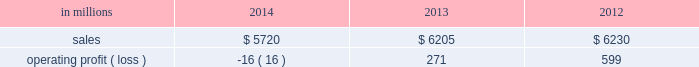Regions .
Principal cost drivers include manufacturing efficiency , raw material and energy costs and freight costs .
Printing papers net sales for 2014 decreased 8% ( 8 % ) to $ 5.7 billion compared with $ 6.2 billion in 2013 and 8% ( 8 % ) compared with $ 6.2 billion in 2012 .
Operating profits in 2014 were 106% ( 106 % ) lower than in 2013 and 103% ( 103 % ) lower than in 2012 .
Excluding facility closure costs , impairment costs and other special items , operating profits in 2014 were 7% ( 7 % ) higher than in 2013 and 8% ( 8 % ) lower than in 2012 .
Benefits from higher average sales price realizations and a favorable mix ( $ 178 million ) , lower planned maintenance downtime costs ( $ 26 million ) , the absence of a provision for bad debt related to a large envelope customer that was booked in 2013 ( $ 28 million ) , and lower foreign exchange and other costs ( $ 25 million ) were offset by lower sales volumes ( $ 82 million ) , higher operating costs ( $ 49 million ) , higher input costs ( $ 47 million ) , and costs associated with the closure of our courtland , alabama mill ( $ 41 million ) .
In addition , operating profits in 2014 include special items costs of $ 554 million associated with the closure of our courtland , alabama mill .
During 2013 , the company accelerated depreciation for certain courtland assets , and evaluated certain other assets for possible alternative uses by one of our other businesses .
The net book value of these assets at december 31 , 2013 was approximately $ 470 million .
In the first quarter of 2014 , we completed our evaluation and concluded that there were no alternative uses for these assets .
We recognized approximately $ 464 million of accelerated depreciation related to these assets in 2014 .
Operating profits in 2014 also include a charge of $ 32 million associated with a foreign tax amnesty program , and a gain of $ 20 million for the resolution of a legal contingency in india , while operating profits in 2013 included costs of $ 118 million associated with the announced closure of our courtland , alabama mill and a $ 123 million impairment charge associated with goodwill and a trade name intangible asset in our india papers business .
Printing papers .
North american printing papers net sales were $ 2.1 billion in 2014 , $ 2.6 billion in 2013 and $ 2.7 billion in 2012 .
Operating profits in 2014 were a loss of $ 398 million ( a gain of $ 156 million excluding costs associated with the shutdown of our courtland , alabama mill ) compared with gains of $ 36 million ( $ 154 million excluding costs associated with the courtland mill shutdown ) in 2013 and $ 331 million in 2012 .
Sales volumes in 2014 decreased compared with 2013 due to lower market demand for uncoated freesheet paper and the closure our courtland mill .
Average sales price realizations were higher , reflecting sales price increases in both domestic and export markets .
Higher input costs for wood were offset by lower costs for chemicals , however freight costs were higher .
Planned maintenance downtime costs were $ 14 million lower in 2014 .
Operating profits in 2014 were negatively impacted by costs associated with the shutdown of our courtland , alabama mill but benefited from the absence of a provision for bad debt related to a large envelope customer that was recorded in 2013 .
Entering the first quarter of 2015 , sales volumes are expected to be stable compared with the fourth quarter of 2014 .
Average sales margins should improve reflecting a more favorable mix although average sales price realizations are expected to be flat .
Input costs are expected to be stable .
Planned maintenance downtime costs are expected to be about $ 16 million lower with an outage scheduled in the 2015 first quarter at our georgetown mill compared with outages at our eastover and riverdale mills in the 2014 fourth quarter .
Brazilian papers net sales for 2014 were $ 1.1 billion compared with $ 1.1 billion in 2013 and $ 1.1 billion in 2012 .
Operating profits for 2014 were $ 177 million ( $ 209 million excluding costs associated with a tax amnesty program ) compared with $ 210 million in 2013 and $ 163 million in 2012 .
Sales volumes in 2014 were about flat compared with 2013 .
Average sales price realizations improved for domestic uncoated freesheet paper due to the realization of price increases implemented in the second half of 2013 and in 2014 .
Margins were favorably affected by an increased proportion of sales to the higher-margin domestic market .
Raw material costs increased for wood and chemicals .
Operating costs were higher than in 2013 and planned maintenance downtime costs were flat .
Looking ahead to 2015 , sales volumes in the first quarter are expected to decrease due to seasonally weaker customer demand for uncoated freesheet paper .
Average sales price improvements are expected to reflect the partial realization of announced sales price increases in the brazilian domestic market for uncoated freesheet paper .
Input costs are expected to be flat .
Planned maintenance outage costs should be $ 5 million lower with an outage scheduled at the luiz antonio mill in the first quarter .
European papers net sales in 2014 were $ 1.5 billion compared with $ 1.5 billion in 2013 and $ 1.4 billion in 2012 .
Operating profits in 2014 were $ 140 million compared with $ 167 million in 2013 and $ 179 million in compared with 2013 , sales volumes for uncoated freesheet paper in 2014 were slightly higher in both .
In 2014 what was the decrease in printing papers net sales in millions? 
Computations: (5.7 - 6.2)
Answer: -0.5. 